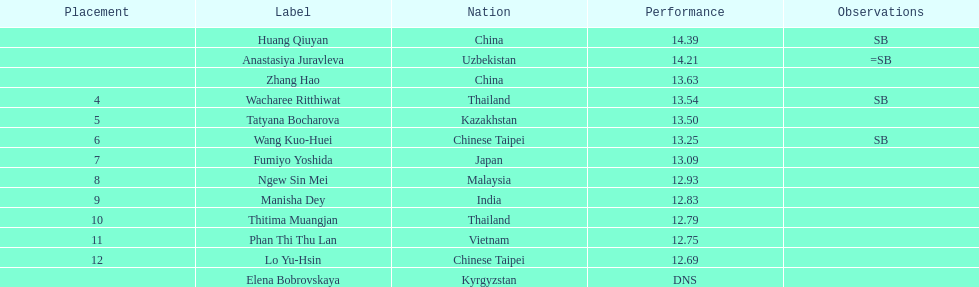Which country had the most competitors ranked in the top three in the event? China. 